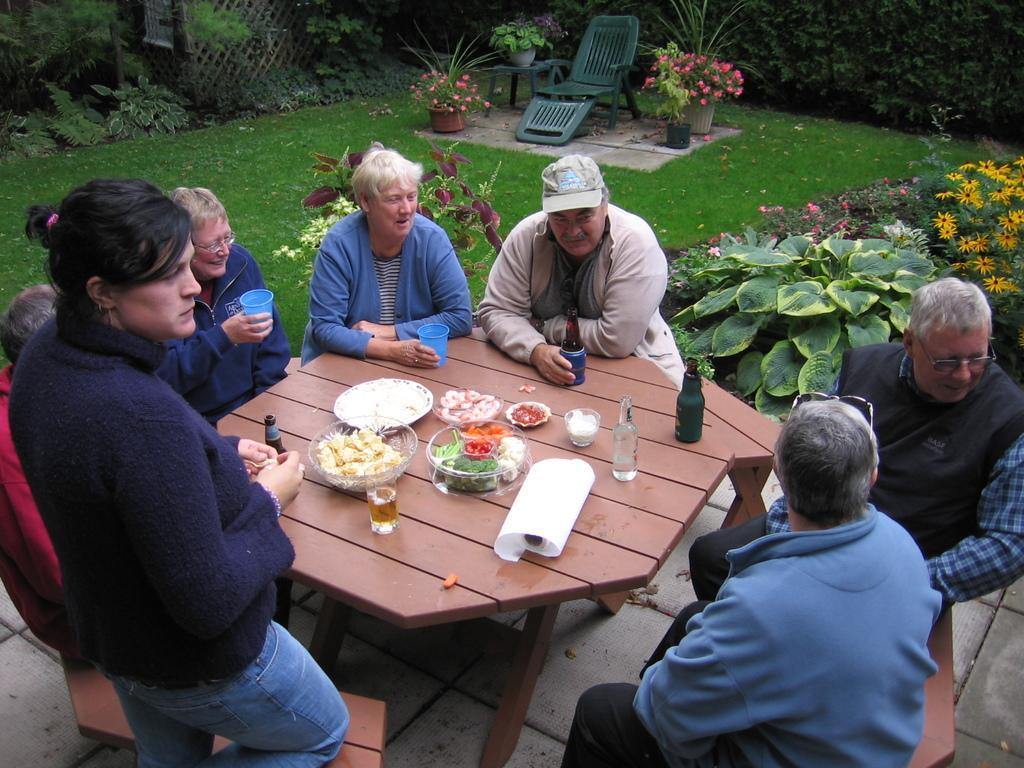Describe this image in one or two sentences. There are so many peoples are sitting and a woman standing in front of a table where there is a food served and bowls behind them there is a beautiful garden with a chair in the middle. 